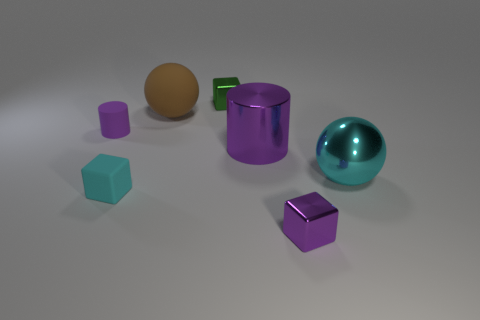Does the brown matte ball have the same size as the cyan shiny thing?
Offer a very short reply. Yes. The matte thing that is the same color as the shiny sphere is what shape?
Make the answer very short. Cube. There is a big metallic sphere that is in front of the large purple cylinder; does it have the same color as the rubber object in front of the big metallic cylinder?
Keep it short and to the point. Yes. Are there more small blocks that are behind the large cyan ball than big gray balls?
Your answer should be very brief. Yes. What is the material of the large purple cylinder?
Your response must be concise. Metal. What is the shape of the cyan object that is made of the same material as the green object?
Keep it short and to the point. Sphere. How big is the sphere in front of the sphere that is on the left side of the large cyan object?
Provide a succinct answer. Large. The matte thing on the left side of the matte block is what color?
Ensure brevity in your answer.  Purple. Are there any small green rubber things that have the same shape as the cyan matte thing?
Provide a succinct answer. No. Are there fewer shiny objects that are behind the cyan shiny ball than objects on the left side of the purple shiny cube?
Make the answer very short. Yes. 